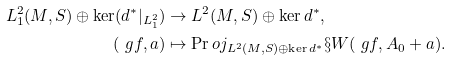Convert formula to latex. <formula><loc_0><loc_0><loc_500><loc_500>L ^ { 2 } _ { 1 } ( M , S ) \oplus \ker ( d ^ { * } | _ { L _ { 1 } ^ { 2 } } ) & \to L ^ { 2 } ( M , S ) \oplus \ker d ^ { * } , \\ ( \ g f , a ) & \mapsto \Pr o j _ { L ^ { 2 } ( M , S ) \oplus \ker d ^ { * } } \S W ( \ g f , A _ { 0 } + a ) .</formula> 